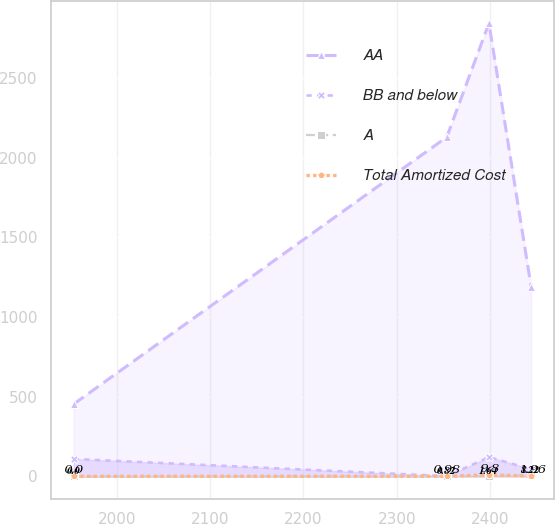Convert chart. <chart><loc_0><loc_0><loc_500><loc_500><line_chart><ecel><fcel>AA<fcel>BB and below<fcel>A<fcel>Total Amortized Cost<nl><fcel>1954.03<fcel>453.93<fcel>109.38<fcel>0<fcel>0<nl><fcel>2353.61<fcel>2130.07<fcel>0.99<fcel>0.82<fcel>0.98<nl><fcel>2398.77<fcel>2844.75<fcel>120.33<fcel>1.64<fcel>9.8<nl><fcel>2443.93<fcel>1191.11<fcel>45.22<fcel>8.22<fcel>1.96<nl></chart> 